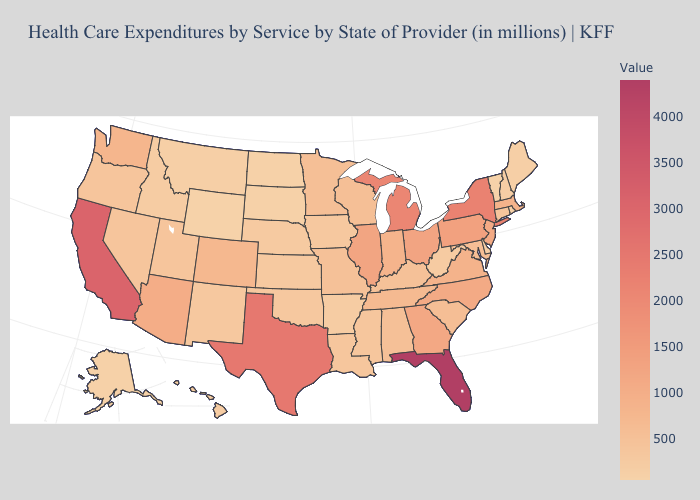Is the legend a continuous bar?
Keep it brief. Yes. Does Delaware have the lowest value in the South?
Concise answer only. Yes. Does California have a lower value than Arizona?
Quick response, please. No. 